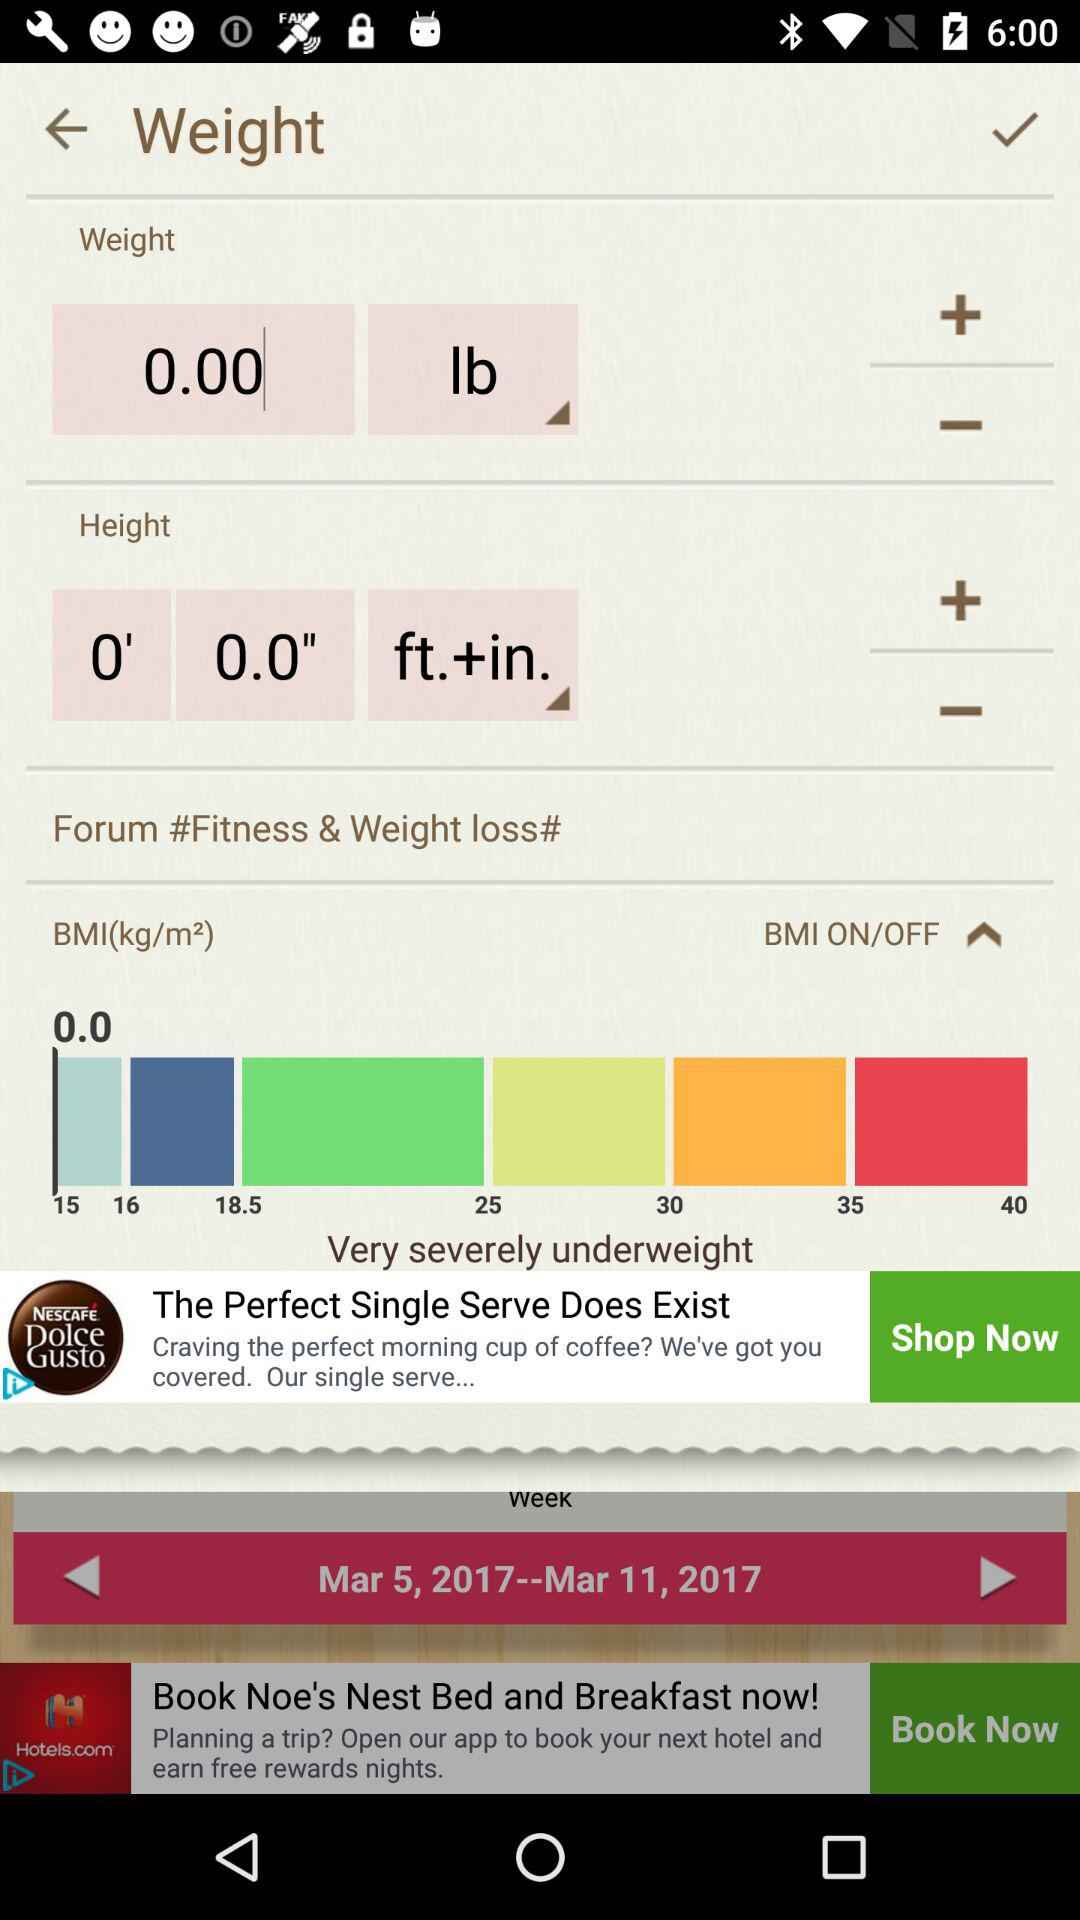What is the BMI value?
Answer the question using a single word or phrase. 0.0 